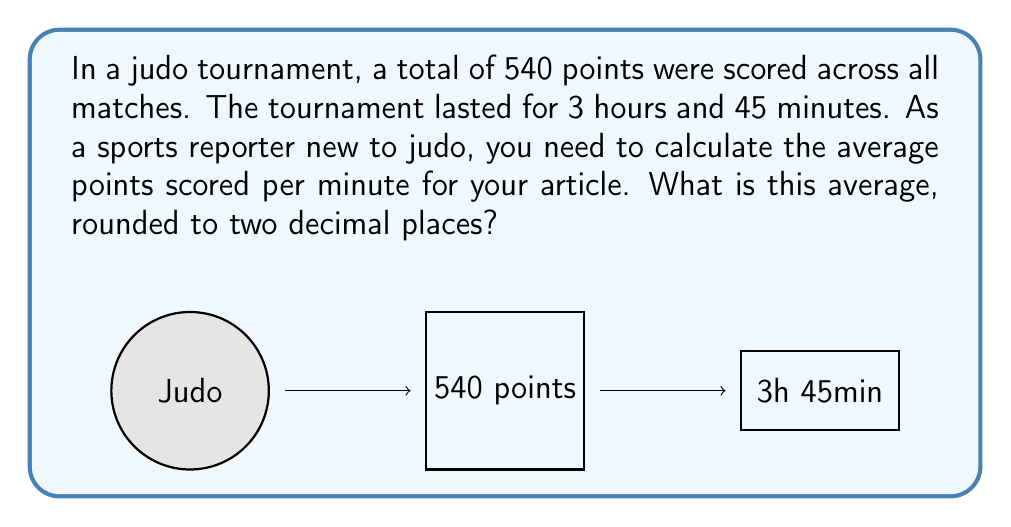Teach me how to tackle this problem. Let's approach this step-by-step:

1) First, we need to convert the tournament duration into minutes:
   $3 \text{ hours } 45 \text{ minutes} = (3 \times 60) + 45 = 225 \text{ minutes}$

2) Now we have:
   - Total points scored: 540
   - Total time in minutes: 225

3) To find the average points per minute, we use the formula:
   $\text{Average} = \frac{\text{Total points}}{\text{Total minutes}}$

4) Substituting our values:
   $\text{Average} = \frac{540}{225}$

5) Simplifying:
   $\text{Average} = \frac{540}{225} = \frac{12}{5} = 2.4$

6) Rounding to two decimal places:
   $2.40 \text{ points per minute}$
Answer: $2.40 \text{ points/minute}$ 